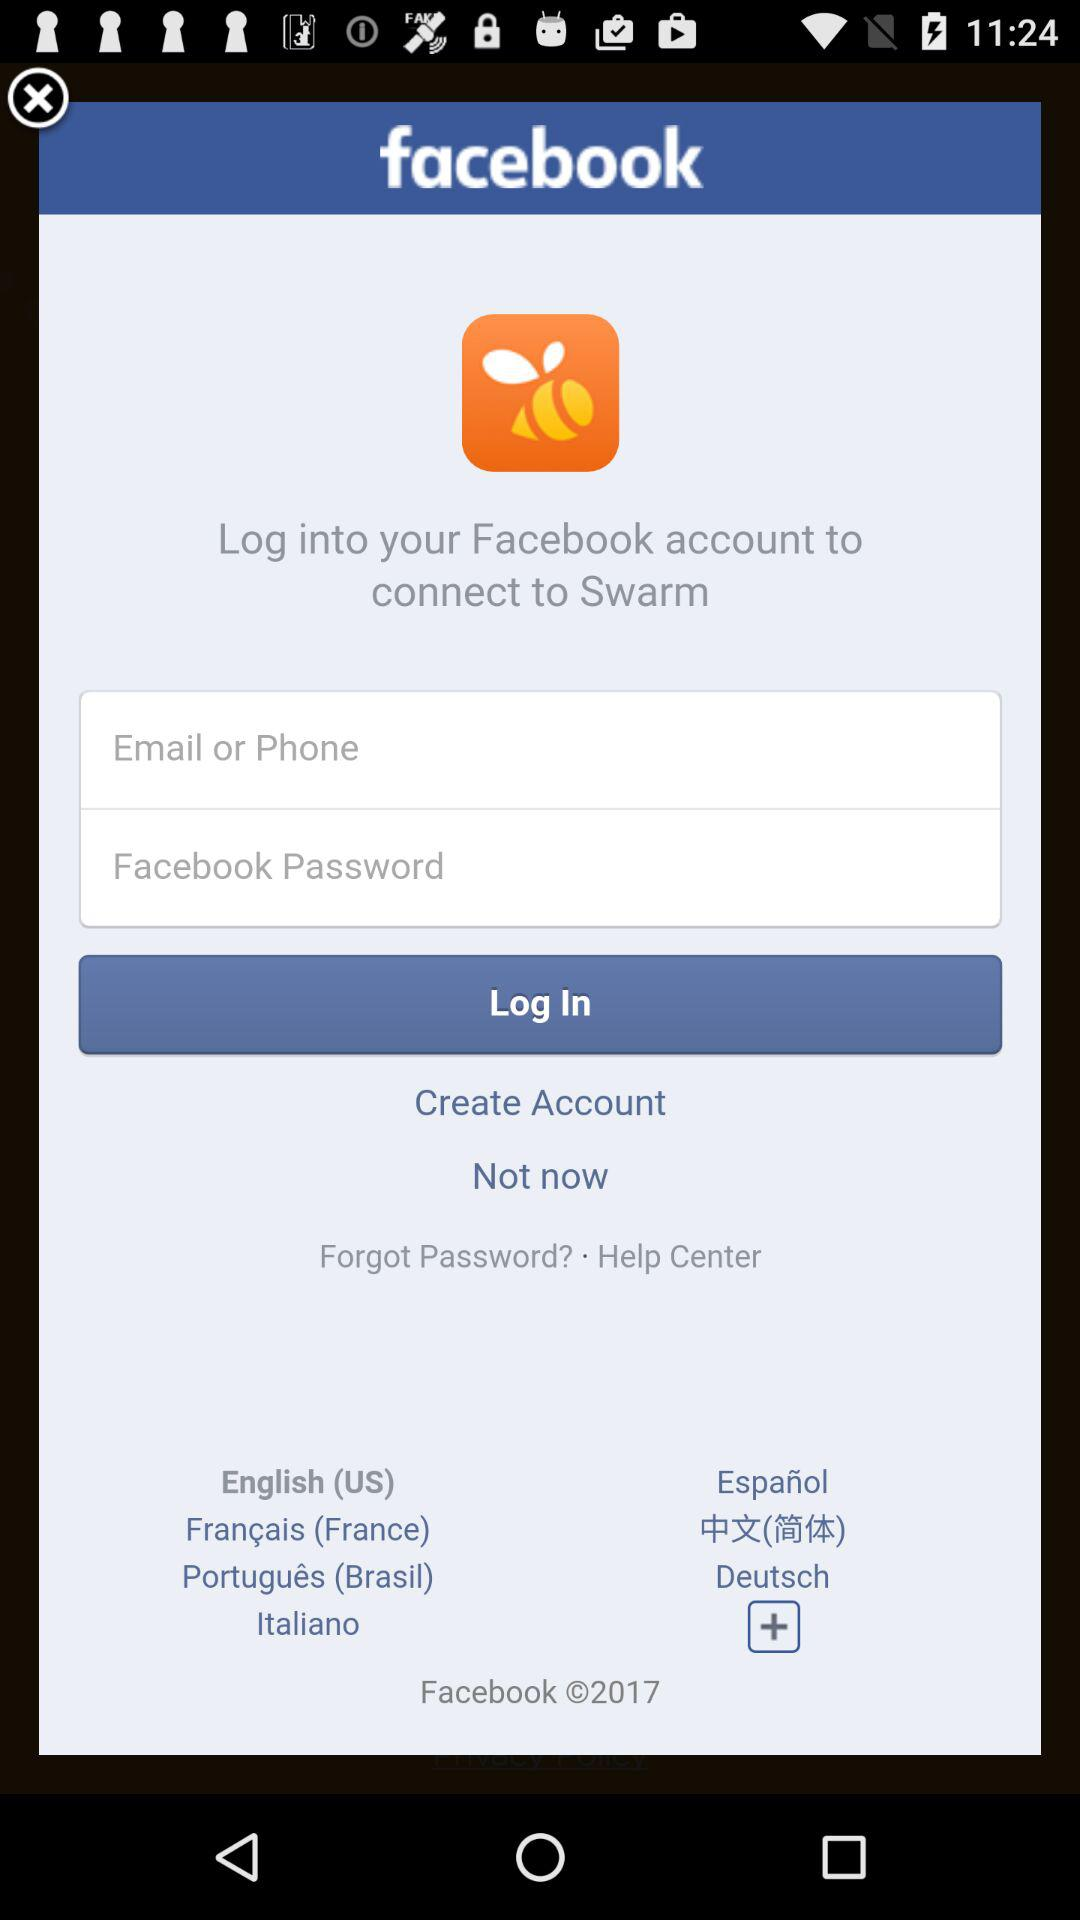Through what application can we log in? You can log in through "Facebook". 